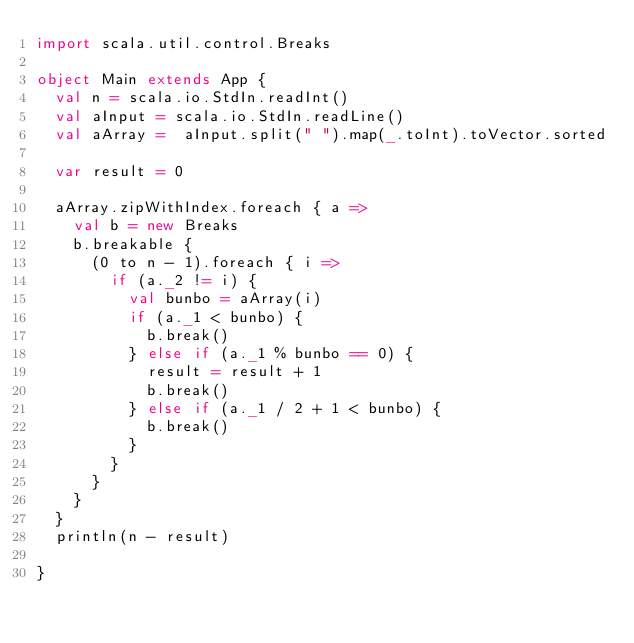<code> <loc_0><loc_0><loc_500><loc_500><_Scala_>import scala.util.control.Breaks

object Main extends App {
  val n = scala.io.StdIn.readInt()
  val aInput = scala.io.StdIn.readLine()
  val aArray =  aInput.split(" ").map(_.toInt).toVector.sorted

  var result = 0

  aArray.zipWithIndex.foreach { a =>
    val b = new Breaks
    b.breakable {
      (0 to n - 1).foreach { i =>
        if (a._2 != i) {
          val bunbo = aArray(i)
          if (a._1 < bunbo) {
            b.break()
          } else if (a._1 % bunbo == 0) {
            result = result + 1
            b.break()
          } else if (a._1 / 2 + 1 < bunbo) {
            b.break()
          }
        }
      }
    }
  }
  println(n - result)

}</code> 